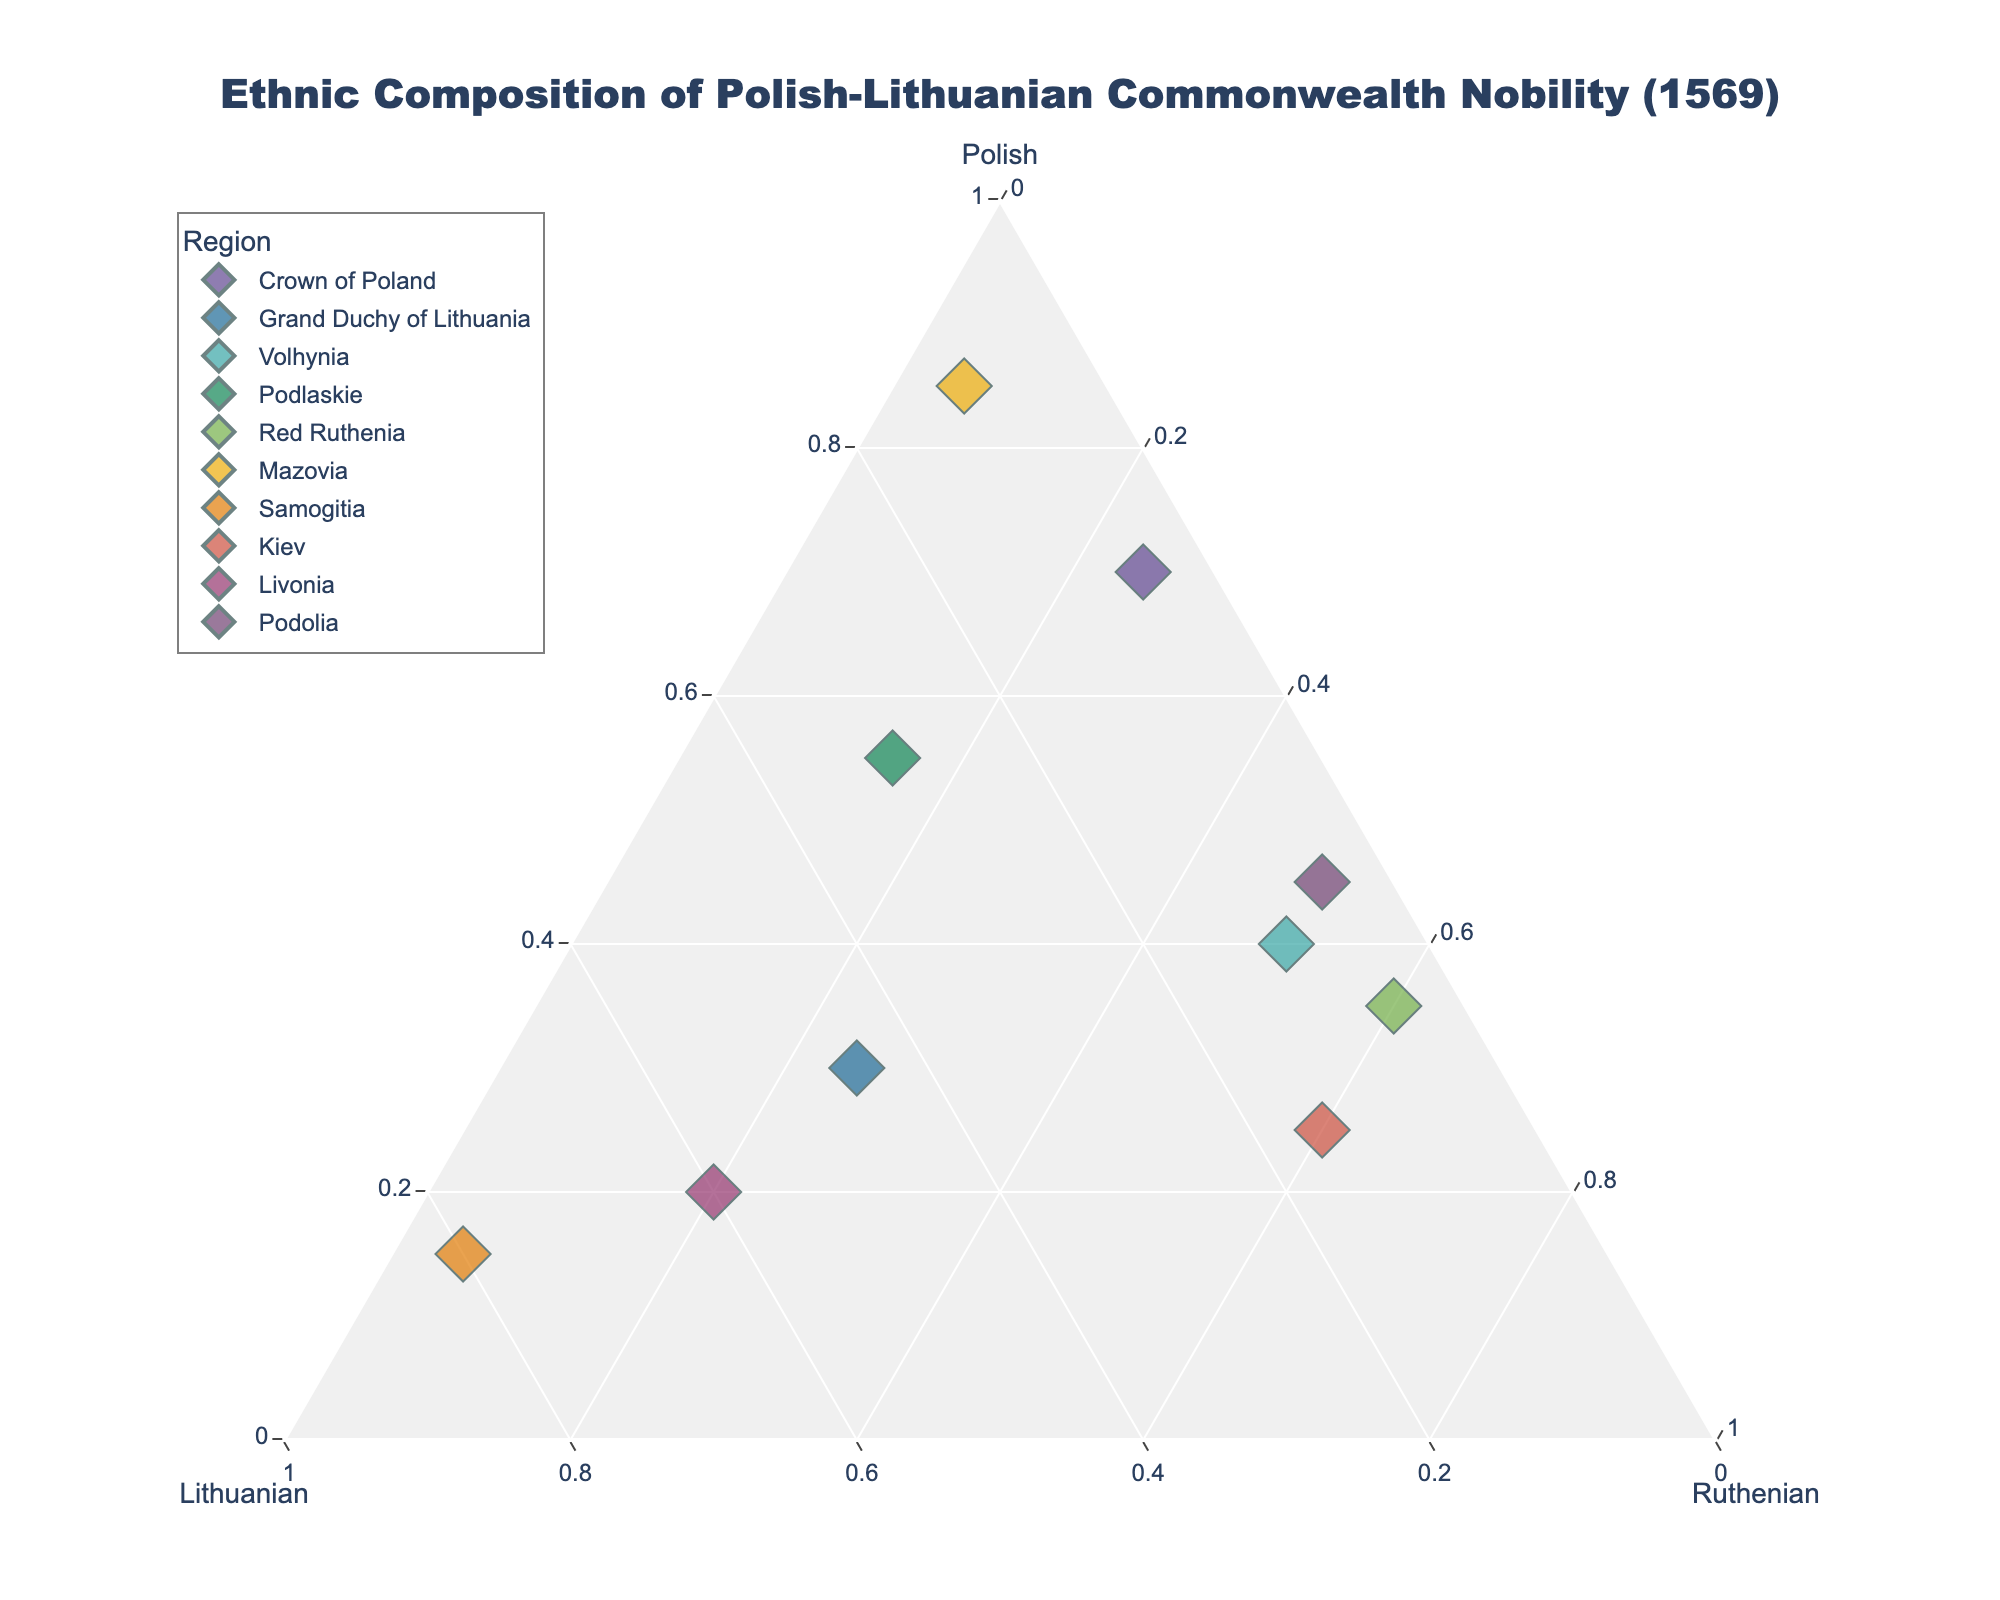what is the title of the figure? The title is displayed at the top center of the figure, usually in a large font.
Answer: Ethnic Composition of Polish-Lithuanian Commonwealth Nobility (1569) Which region has the highest percentage of Polish nobility? Examine the position of the data points near the "Polish" vertex of the ternary plot. The point closest to the Polish axis represents the highest percentage of Polish nobility.
Answer: Mazovia How many regions are displayed in the plot? Count the distinct data points on the ternary plot.
Answer: 10 Which region has the highest percentage of Lithuanian nobility? Look for the data point closest to the Lithuanian vertex. The closest point denotes the highest Lithuanian percentage.
Answer: Samogitia Do any regions have 60% Ruthenian nobility? Identify data points aligned with the 60% mark on the Ruthenian axis.
Answer: Yes, Kiev and Red Ruthenia Which region has a more balanced ethnic composition (similar values for all three ethnic groups)? Assess points near the center of the plot where coordinates appear more evenly distributed among the three groups.
Answer: Grand Duchy of Lithuania What is the difference in Polish nobility percentage between Mazovia and Samogitia? Subtract the percentage of Polish nobility in Samogitia from that in Mazovia.
Answer: 70 Which region has the lowest percentage of Lithuanian nobility? Identify the region farthest from the Lithuanian vertex.
Answer: Volhynia Compare the percentage of Ruthenian nobility in Volhynia and Podolia. Locate both regions on the plot, then compare their positions along the Ruthenian axis.
Answer: Equal (Both have 50%) What is the total combined percentage of Polish and Ruthenian nobility in Red Ruthenia? Sum up the percentages of Polish and Ruthenian nobility for Red Ruthenia.
Answer: 95 